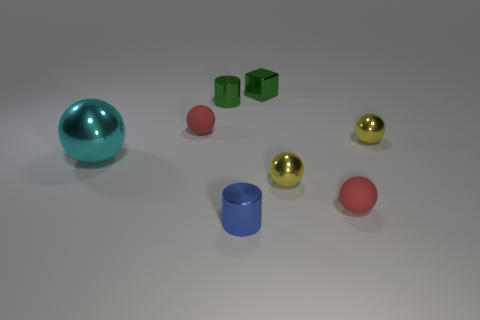How many small objects are either shiny spheres or matte things?
Provide a succinct answer. 4. There is a cube that is made of the same material as the big cyan ball; what is its color?
Your answer should be compact. Green. Is the shape of the rubber thing that is in front of the big cyan metallic sphere the same as the red matte object that is to the left of the tiny blue object?
Your answer should be compact. Yes. What number of rubber objects are either green cylinders or big gray objects?
Keep it short and to the point. 0. What is the material of the tiny object that is the same color as the metallic cube?
Ensure brevity in your answer.  Metal. Is there any other thing that is the same shape as the small blue thing?
Provide a short and direct response. Yes. What material is the tiny red ball in front of the big sphere?
Make the answer very short. Rubber. Is the material of the tiny red sphere on the right side of the green metallic block the same as the small cube?
Keep it short and to the point. No. What number of objects are either large green matte blocks or shiny balls that are in front of the big cyan object?
Give a very brief answer. 1. There is a green object that is the same shape as the tiny blue thing; what size is it?
Keep it short and to the point. Small. 